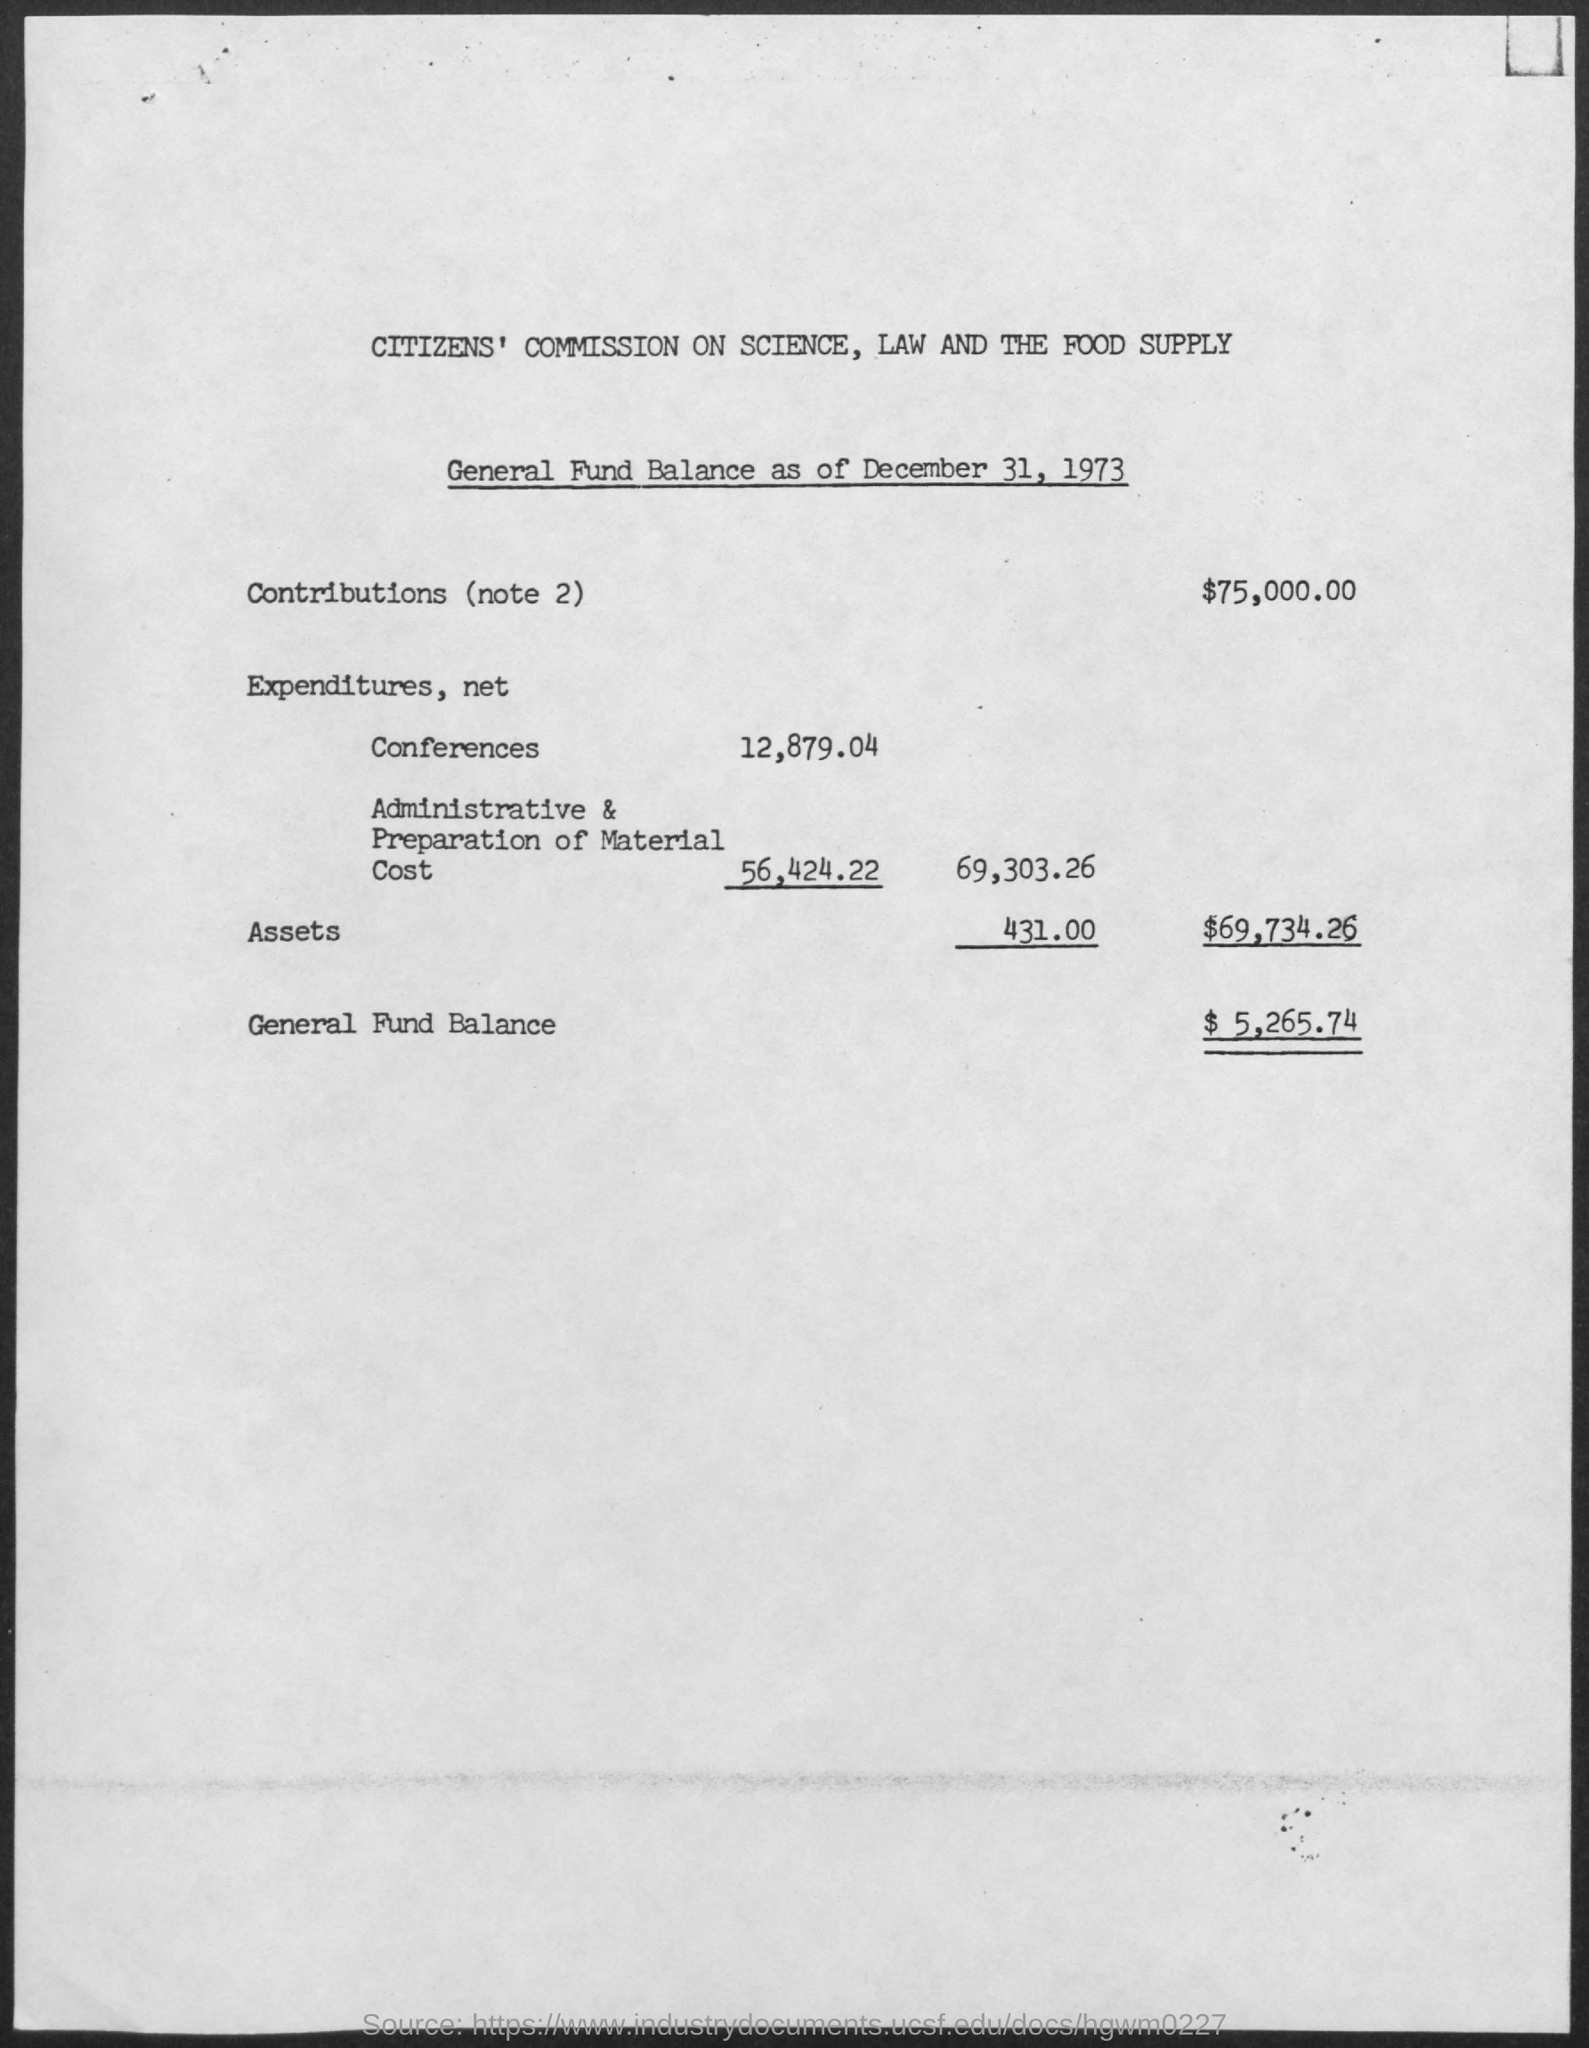What is the document about?
Your answer should be compact. General Fund Balance as of December 31, 1973. What is the amount of contributions (note 2)?
Ensure brevity in your answer.  $75,000.00. How much is the general fund balance?
Provide a succinct answer. $ 5,265.74. Which institution is mentioned at the top of the page?
Provide a short and direct response. Citizens' Commission On Science, Law and the Food Supply. 